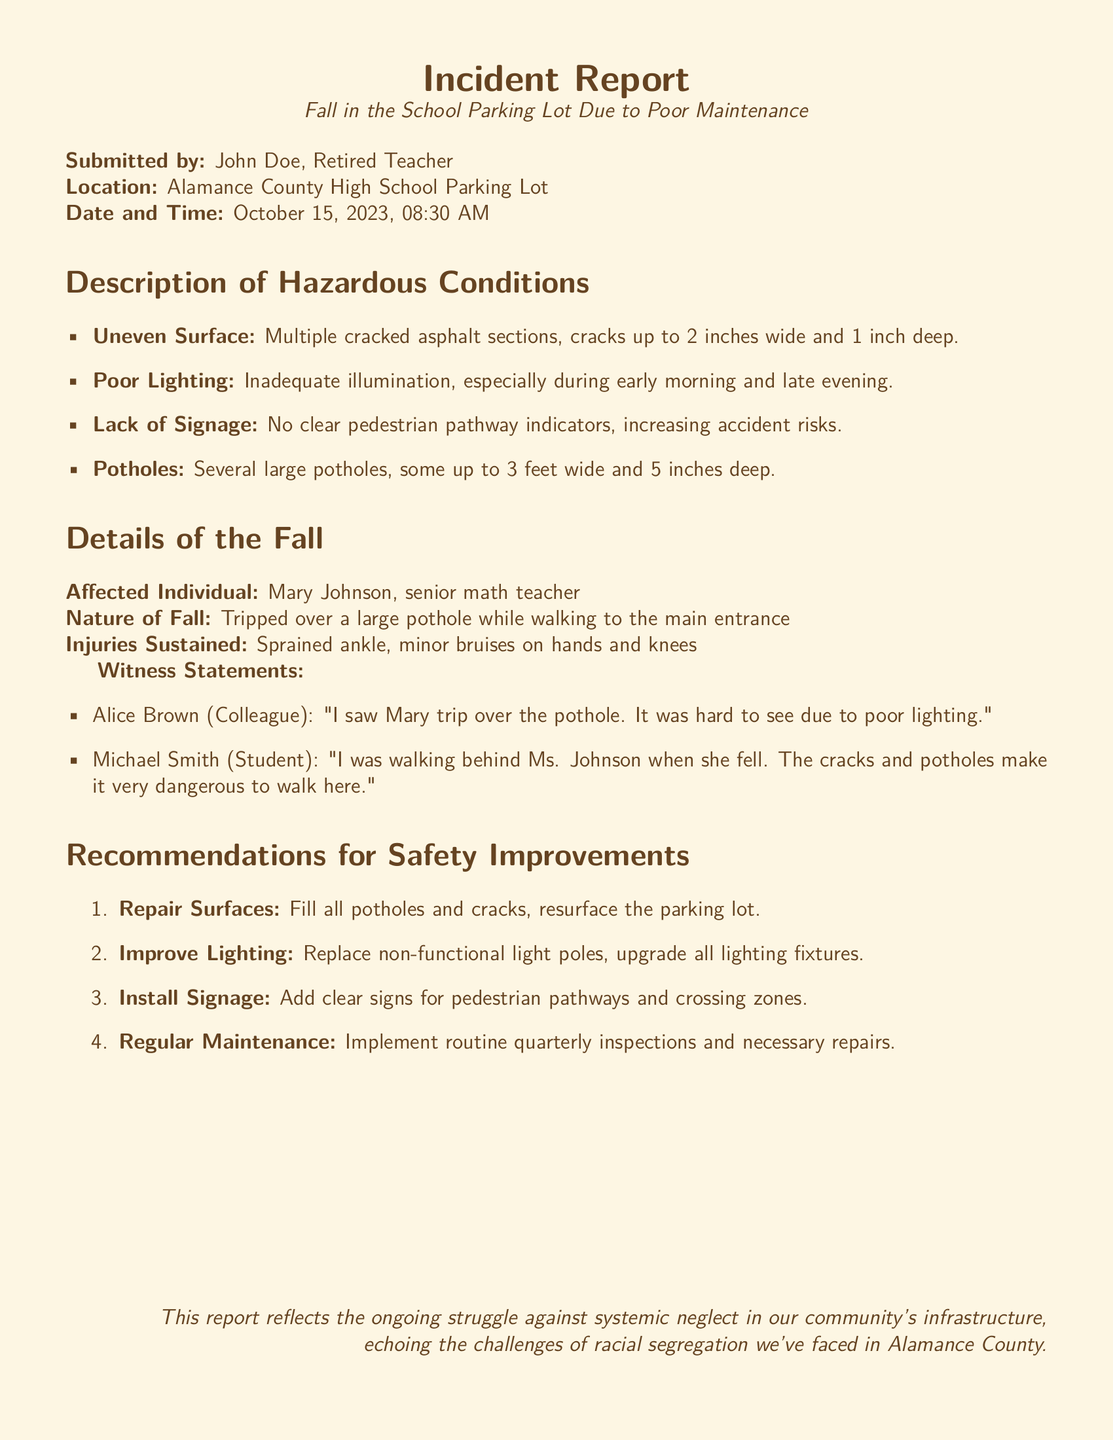What is the date of the incident? The date of the incident is stated in the report as October 15, 2023.
Answer: October 15, 2023 Who is the affected individual? The report identifies the individual affected by the incident as Mary Johnson.
Answer: Mary Johnson What type of injuries did the affected individual sustain? The report provides details about the injuries, specifying they are a sprained ankle and minor bruises.
Answer: Sprained ankle, minor bruises What is one of the hazardous conditions mentioned? The report lists multiple hazardous conditions, one being "multiple cracked asphalt sections."
Answer: Multiple cracked asphalt sections How deep were the cracks mentioned in the report? The dimensions of the cracks are detailed in the report, stating they are up to 1 inch deep.
Answer: 1 inch deep What improvement is recommended for lighting? The recommendations for safety improvements include replacing non-functional light poles.
Answer: Replace non-functional light poles How wide can the reported potholes be? The report specifies that some potholes are up to 3 feet wide.
Answer: 3 feet wide What is the name of a witness to the fall? The report includes witness statements, and one witness mentioned is Alice Brown.
Answer: Alice Brown What should be implemented regularly according to the recommendations? The report suggests implementing routine quarterly inspections.
Answer: Routine quarterly inspections 